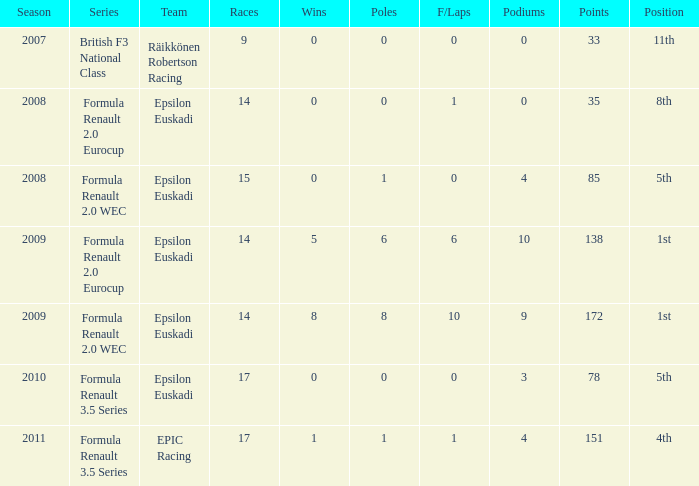What was the total number of podiums he reached while competing in the british f3 national class series? 1.0. 